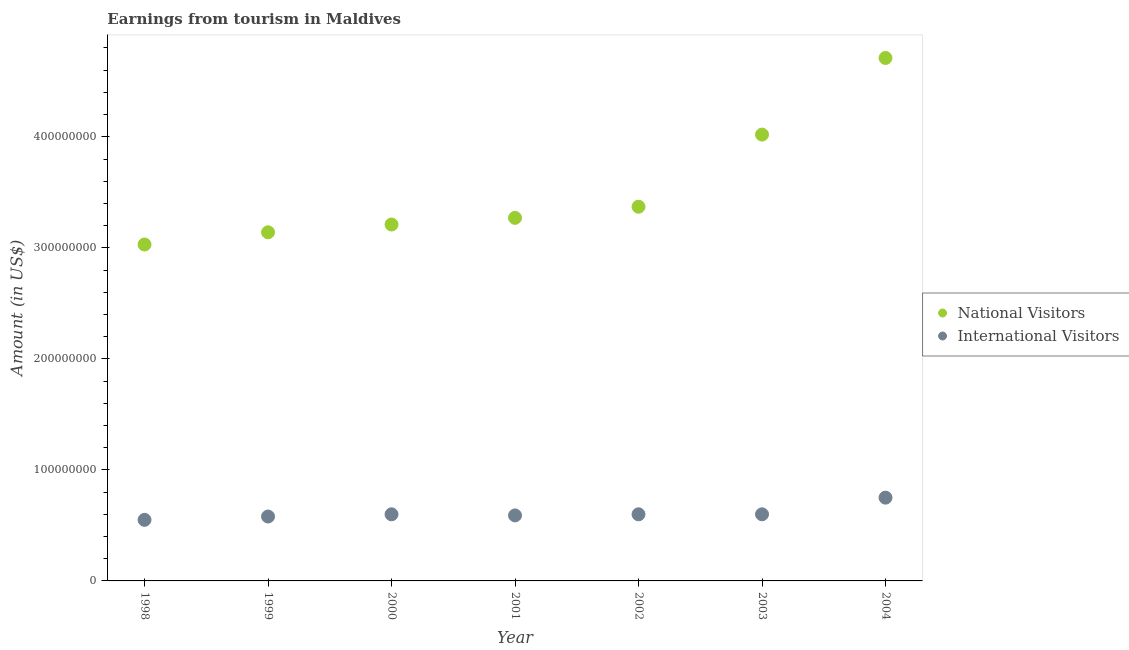How many different coloured dotlines are there?
Your response must be concise. 2. Is the number of dotlines equal to the number of legend labels?
Give a very brief answer. Yes. What is the amount earned from international visitors in 2001?
Offer a terse response. 5.90e+07. Across all years, what is the maximum amount earned from international visitors?
Keep it short and to the point. 7.50e+07. Across all years, what is the minimum amount earned from national visitors?
Provide a short and direct response. 3.03e+08. In which year was the amount earned from international visitors minimum?
Offer a terse response. 1998. What is the total amount earned from international visitors in the graph?
Ensure brevity in your answer.  4.27e+08. What is the difference between the amount earned from international visitors in 1998 and that in 2002?
Keep it short and to the point. -5.00e+06. What is the difference between the amount earned from international visitors in 2000 and the amount earned from national visitors in 2004?
Your answer should be compact. -4.11e+08. What is the average amount earned from international visitors per year?
Your response must be concise. 6.10e+07. In the year 2002, what is the difference between the amount earned from international visitors and amount earned from national visitors?
Your response must be concise. -2.77e+08. What is the ratio of the amount earned from national visitors in 1999 to that in 2004?
Your answer should be compact. 0.67. Is the amount earned from national visitors in 2002 less than that in 2004?
Provide a short and direct response. Yes. Is the difference between the amount earned from national visitors in 2000 and 2001 greater than the difference between the amount earned from international visitors in 2000 and 2001?
Ensure brevity in your answer.  No. What is the difference between the highest and the second highest amount earned from national visitors?
Your response must be concise. 6.90e+07. What is the difference between the highest and the lowest amount earned from international visitors?
Provide a succinct answer. 2.00e+07. In how many years, is the amount earned from international visitors greater than the average amount earned from international visitors taken over all years?
Provide a short and direct response. 1. Is the amount earned from international visitors strictly less than the amount earned from national visitors over the years?
Offer a very short reply. Yes. How many dotlines are there?
Keep it short and to the point. 2. How many years are there in the graph?
Your answer should be very brief. 7. What is the difference between two consecutive major ticks on the Y-axis?
Ensure brevity in your answer.  1.00e+08. Are the values on the major ticks of Y-axis written in scientific E-notation?
Offer a very short reply. No. Does the graph contain grids?
Your answer should be compact. No. How many legend labels are there?
Your answer should be compact. 2. How are the legend labels stacked?
Make the answer very short. Vertical. What is the title of the graph?
Provide a succinct answer. Earnings from tourism in Maldives. What is the label or title of the Y-axis?
Keep it short and to the point. Amount (in US$). What is the Amount (in US$) of National Visitors in 1998?
Your answer should be compact. 3.03e+08. What is the Amount (in US$) of International Visitors in 1998?
Provide a short and direct response. 5.50e+07. What is the Amount (in US$) in National Visitors in 1999?
Offer a terse response. 3.14e+08. What is the Amount (in US$) of International Visitors in 1999?
Offer a very short reply. 5.80e+07. What is the Amount (in US$) of National Visitors in 2000?
Offer a terse response. 3.21e+08. What is the Amount (in US$) in International Visitors in 2000?
Your response must be concise. 6.00e+07. What is the Amount (in US$) of National Visitors in 2001?
Your answer should be very brief. 3.27e+08. What is the Amount (in US$) of International Visitors in 2001?
Your answer should be very brief. 5.90e+07. What is the Amount (in US$) of National Visitors in 2002?
Your answer should be very brief. 3.37e+08. What is the Amount (in US$) of International Visitors in 2002?
Your response must be concise. 6.00e+07. What is the Amount (in US$) in National Visitors in 2003?
Keep it short and to the point. 4.02e+08. What is the Amount (in US$) in International Visitors in 2003?
Make the answer very short. 6.00e+07. What is the Amount (in US$) in National Visitors in 2004?
Keep it short and to the point. 4.71e+08. What is the Amount (in US$) of International Visitors in 2004?
Your answer should be very brief. 7.50e+07. Across all years, what is the maximum Amount (in US$) of National Visitors?
Make the answer very short. 4.71e+08. Across all years, what is the maximum Amount (in US$) of International Visitors?
Provide a succinct answer. 7.50e+07. Across all years, what is the minimum Amount (in US$) of National Visitors?
Provide a short and direct response. 3.03e+08. Across all years, what is the minimum Amount (in US$) in International Visitors?
Offer a terse response. 5.50e+07. What is the total Amount (in US$) in National Visitors in the graph?
Make the answer very short. 2.48e+09. What is the total Amount (in US$) in International Visitors in the graph?
Your response must be concise. 4.27e+08. What is the difference between the Amount (in US$) of National Visitors in 1998 and that in 1999?
Provide a short and direct response. -1.10e+07. What is the difference between the Amount (in US$) of International Visitors in 1998 and that in 1999?
Keep it short and to the point. -3.00e+06. What is the difference between the Amount (in US$) in National Visitors in 1998 and that in 2000?
Provide a succinct answer. -1.80e+07. What is the difference between the Amount (in US$) in International Visitors in 1998 and that in 2000?
Make the answer very short. -5.00e+06. What is the difference between the Amount (in US$) of National Visitors in 1998 and that in 2001?
Give a very brief answer. -2.40e+07. What is the difference between the Amount (in US$) of National Visitors in 1998 and that in 2002?
Offer a very short reply. -3.40e+07. What is the difference between the Amount (in US$) of International Visitors in 1998 and that in 2002?
Give a very brief answer. -5.00e+06. What is the difference between the Amount (in US$) in National Visitors in 1998 and that in 2003?
Keep it short and to the point. -9.90e+07. What is the difference between the Amount (in US$) in International Visitors in 1998 and that in 2003?
Provide a short and direct response. -5.00e+06. What is the difference between the Amount (in US$) of National Visitors in 1998 and that in 2004?
Ensure brevity in your answer.  -1.68e+08. What is the difference between the Amount (in US$) of International Visitors in 1998 and that in 2004?
Offer a very short reply. -2.00e+07. What is the difference between the Amount (in US$) of National Visitors in 1999 and that in 2000?
Your answer should be compact. -7.00e+06. What is the difference between the Amount (in US$) of National Visitors in 1999 and that in 2001?
Offer a very short reply. -1.30e+07. What is the difference between the Amount (in US$) of National Visitors in 1999 and that in 2002?
Provide a succinct answer. -2.30e+07. What is the difference between the Amount (in US$) in National Visitors in 1999 and that in 2003?
Offer a terse response. -8.80e+07. What is the difference between the Amount (in US$) of International Visitors in 1999 and that in 2003?
Ensure brevity in your answer.  -2.00e+06. What is the difference between the Amount (in US$) in National Visitors in 1999 and that in 2004?
Provide a short and direct response. -1.57e+08. What is the difference between the Amount (in US$) in International Visitors in 1999 and that in 2004?
Your answer should be very brief. -1.70e+07. What is the difference between the Amount (in US$) of National Visitors in 2000 and that in 2001?
Provide a succinct answer. -6.00e+06. What is the difference between the Amount (in US$) in National Visitors in 2000 and that in 2002?
Offer a very short reply. -1.60e+07. What is the difference between the Amount (in US$) in National Visitors in 2000 and that in 2003?
Provide a succinct answer. -8.10e+07. What is the difference between the Amount (in US$) of National Visitors in 2000 and that in 2004?
Your answer should be compact. -1.50e+08. What is the difference between the Amount (in US$) in International Visitors in 2000 and that in 2004?
Offer a terse response. -1.50e+07. What is the difference between the Amount (in US$) of National Visitors in 2001 and that in 2002?
Offer a terse response. -1.00e+07. What is the difference between the Amount (in US$) in International Visitors in 2001 and that in 2002?
Your response must be concise. -1.00e+06. What is the difference between the Amount (in US$) in National Visitors in 2001 and that in 2003?
Make the answer very short. -7.50e+07. What is the difference between the Amount (in US$) in National Visitors in 2001 and that in 2004?
Offer a terse response. -1.44e+08. What is the difference between the Amount (in US$) in International Visitors in 2001 and that in 2004?
Give a very brief answer. -1.60e+07. What is the difference between the Amount (in US$) of National Visitors in 2002 and that in 2003?
Ensure brevity in your answer.  -6.50e+07. What is the difference between the Amount (in US$) of National Visitors in 2002 and that in 2004?
Provide a short and direct response. -1.34e+08. What is the difference between the Amount (in US$) of International Visitors in 2002 and that in 2004?
Make the answer very short. -1.50e+07. What is the difference between the Amount (in US$) of National Visitors in 2003 and that in 2004?
Offer a terse response. -6.90e+07. What is the difference between the Amount (in US$) in International Visitors in 2003 and that in 2004?
Your answer should be very brief. -1.50e+07. What is the difference between the Amount (in US$) of National Visitors in 1998 and the Amount (in US$) of International Visitors in 1999?
Make the answer very short. 2.45e+08. What is the difference between the Amount (in US$) of National Visitors in 1998 and the Amount (in US$) of International Visitors in 2000?
Offer a terse response. 2.43e+08. What is the difference between the Amount (in US$) in National Visitors in 1998 and the Amount (in US$) in International Visitors in 2001?
Your answer should be very brief. 2.44e+08. What is the difference between the Amount (in US$) in National Visitors in 1998 and the Amount (in US$) in International Visitors in 2002?
Make the answer very short. 2.43e+08. What is the difference between the Amount (in US$) of National Visitors in 1998 and the Amount (in US$) of International Visitors in 2003?
Offer a terse response. 2.43e+08. What is the difference between the Amount (in US$) in National Visitors in 1998 and the Amount (in US$) in International Visitors in 2004?
Keep it short and to the point. 2.28e+08. What is the difference between the Amount (in US$) of National Visitors in 1999 and the Amount (in US$) of International Visitors in 2000?
Offer a terse response. 2.54e+08. What is the difference between the Amount (in US$) in National Visitors in 1999 and the Amount (in US$) in International Visitors in 2001?
Give a very brief answer. 2.55e+08. What is the difference between the Amount (in US$) of National Visitors in 1999 and the Amount (in US$) of International Visitors in 2002?
Provide a succinct answer. 2.54e+08. What is the difference between the Amount (in US$) in National Visitors in 1999 and the Amount (in US$) in International Visitors in 2003?
Make the answer very short. 2.54e+08. What is the difference between the Amount (in US$) of National Visitors in 1999 and the Amount (in US$) of International Visitors in 2004?
Keep it short and to the point. 2.39e+08. What is the difference between the Amount (in US$) in National Visitors in 2000 and the Amount (in US$) in International Visitors in 2001?
Your response must be concise. 2.62e+08. What is the difference between the Amount (in US$) in National Visitors in 2000 and the Amount (in US$) in International Visitors in 2002?
Keep it short and to the point. 2.61e+08. What is the difference between the Amount (in US$) of National Visitors in 2000 and the Amount (in US$) of International Visitors in 2003?
Provide a short and direct response. 2.61e+08. What is the difference between the Amount (in US$) of National Visitors in 2000 and the Amount (in US$) of International Visitors in 2004?
Ensure brevity in your answer.  2.46e+08. What is the difference between the Amount (in US$) of National Visitors in 2001 and the Amount (in US$) of International Visitors in 2002?
Offer a very short reply. 2.67e+08. What is the difference between the Amount (in US$) of National Visitors in 2001 and the Amount (in US$) of International Visitors in 2003?
Offer a very short reply. 2.67e+08. What is the difference between the Amount (in US$) in National Visitors in 2001 and the Amount (in US$) in International Visitors in 2004?
Give a very brief answer. 2.52e+08. What is the difference between the Amount (in US$) in National Visitors in 2002 and the Amount (in US$) in International Visitors in 2003?
Offer a terse response. 2.77e+08. What is the difference between the Amount (in US$) in National Visitors in 2002 and the Amount (in US$) in International Visitors in 2004?
Offer a very short reply. 2.62e+08. What is the difference between the Amount (in US$) of National Visitors in 2003 and the Amount (in US$) of International Visitors in 2004?
Provide a succinct answer. 3.27e+08. What is the average Amount (in US$) in National Visitors per year?
Your answer should be very brief. 3.54e+08. What is the average Amount (in US$) of International Visitors per year?
Provide a succinct answer. 6.10e+07. In the year 1998, what is the difference between the Amount (in US$) of National Visitors and Amount (in US$) of International Visitors?
Provide a short and direct response. 2.48e+08. In the year 1999, what is the difference between the Amount (in US$) in National Visitors and Amount (in US$) in International Visitors?
Your answer should be very brief. 2.56e+08. In the year 2000, what is the difference between the Amount (in US$) of National Visitors and Amount (in US$) of International Visitors?
Offer a very short reply. 2.61e+08. In the year 2001, what is the difference between the Amount (in US$) of National Visitors and Amount (in US$) of International Visitors?
Offer a terse response. 2.68e+08. In the year 2002, what is the difference between the Amount (in US$) of National Visitors and Amount (in US$) of International Visitors?
Offer a terse response. 2.77e+08. In the year 2003, what is the difference between the Amount (in US$) of National Visitors and Amount (in US$) of International Visitors?
Provide a short and direct response. 3.42e+08. In the year 2004, what is the difference between the Amount (in US$) in National Visitors and Amount (in US$) in International Visitors?
Provide a short and direct response. 3.96e+08. What is the ratio of the Amount (in US$) in National Visitors in 1998 to that in 1999?
Your response must be concise. 0.96. What is the ratio of the Amount (in US$) of International Visitors in 1998 to that in 1999?
Offer a very short reply. 0.95. What is the ratio of the Amount (in US$) in National Visitors in 1998 to that in 2000?
Offer a terse response. 0.94. What is the ratio of the Amount (in US$) of International Visitors in 1998 to that in 2000?
Your response must be concise. 0.92. What is the ratio of the Amount (in US$) of National Visitors in 1998 to that in 2001?
Keep it short and to the point. 0.93. What is the ratio of the Amount (in US$) in International Visitors in 1998 to that in 2001?
Provide a succinct answer. 0.93. What is the ratio of the Amount (in US$) in National Visitors in 1998 to that in 2002?
Your answer should be compact. 0.9. What is the ratio of the Amount (in US$) of National Visitors in 1998 to that in 2003?
Provide a succinct answer. 0.75. What is the ratio of the Amount (in US$) of National Visitors in 1998 to that in 2004?
Offer a terse response. 0.64. What is the ratio of the Amount (in US$) of International Visitors in 1998 to that in 2004?
Provide a short and direct response. 0.73. What is the ratio of the Amount (in US$) in National Visitors in 1999 to that in 2000?
Offer a very short reply. 0.98. What is the ratio of the Amount (in US$) of International Visitors in 1999 to that in 2000?
Make the answer very short. 0.97. What is the ratio of the Amount (in US$) of National Visitors in 1999 to that in 2001?
Your response must be concise. 0.96. What is the ratio of the Amount (in US$) of International Visitors in 1999 to that in 2001?
Make the answer very short. 0.98. What is the ratio of the Amount (in US$) of National Visitors in 1999 to that in 2002?
Your answer should be very brief. 0.93. What is the ratio of the Amount (in US$) of International Visitors in 1999 to that in 2002?
Give a very brief answer. 0.97. What is the ratio of the Amount (in US$) of National Visitors in 1999 to that in 2003?
Make the answer very short. 0.78. What is the ratio of the Amount (in US$) in International Visitors in 1999 to that in 2003?
Provide a succinct answer. 0.97. What is the ratio of the Amount (in US$) of National Visitors in 1999 to that in 2004?
Provide a succinct answer. 0.67. What is the ratio of the Amount (in US$) of International Visitors in 1999 to that in 2004?
Ensure brevity in your answer.  0.77. What is the ratio of the Amount (in US$) in National Visitors in 2000 to that in 2001?
Keep it short and to the point. 0.98. What is the ratio of the Amount (in US$) in International Visitors in 2000 to that in 2001?
Provide a short and direct response. 1.02. What is the ratio of the Amount (in US$) of National Visitors in 2000 to that in 2002?
Your answer should be compact. 0.95. What is the ratio of the Amount (in US$) in National Visitors in 2000 to that in 2003?
Make the answer very short. 0.8. What is the ratio of the Amount (in US$) in National Visitors in 2000 to that in 2004?
Your answer should be compact. 0.68. What is the ratio of the Amount (in US$) of National Visitors in 2001 to that in 2002?
Provide a short and direct response. 0.97. What is the ratio of the Amount (in US$) of International Visitors in 2001 to that in 2002?
Ensure brevity in your answer.  0.98. What is the ratio of the Amount (in US$) of National Visitors in 2001 to that in 2003?
Give a very brief answer. 0.81. What is the ratio of the Amount (in US$) of International Visitors in 2001 to that in 2003?
Your response must be concise. 0.98. What is the ratio of the Amount (in US$) in National Visitors in 2001 to that in 2004?
Provide a succinct answer. 0.69. What is the ratio of the Amount (in US$) of International Visitors in 2001 to that in 2004?
Your answer should be very brief. 0.79. What is the ratio of the Amount (in US$) of National Visitors in 2002 to that in 2003?
Make the answer very short. 0.84. What is the ratio of the Amount (in US$) in International Visitors in 2002 to that in 2003?
Your answer should be very brief. 1. What is the ratio of the Amount (in US$) of National Visitors in 2002 to that in 2004?
Give a very brief answer. 0.72. What is the ratio of the Amount (in US$) in International Visitors in 2002 to that in 2004?
Ensure brevity in your answer.  0.8. What is the ratio of the Amount (in US$) of National Visitors in 2003 to that in 2004?
Offer a very short reply. 0.85. What is the difference between the highest and the second highest Amount (in US$) in National Visitors?
Your response must be concise. 6.90e+07. What is the difference between the highest and the second highest Amount (in US$) of International Visitors?
Make the answer very short. 1.50e+07. What is the difference between the highest and the lowest Amount (in US$) in National Visitors?
Make the answer very short. 1.68e+08. 